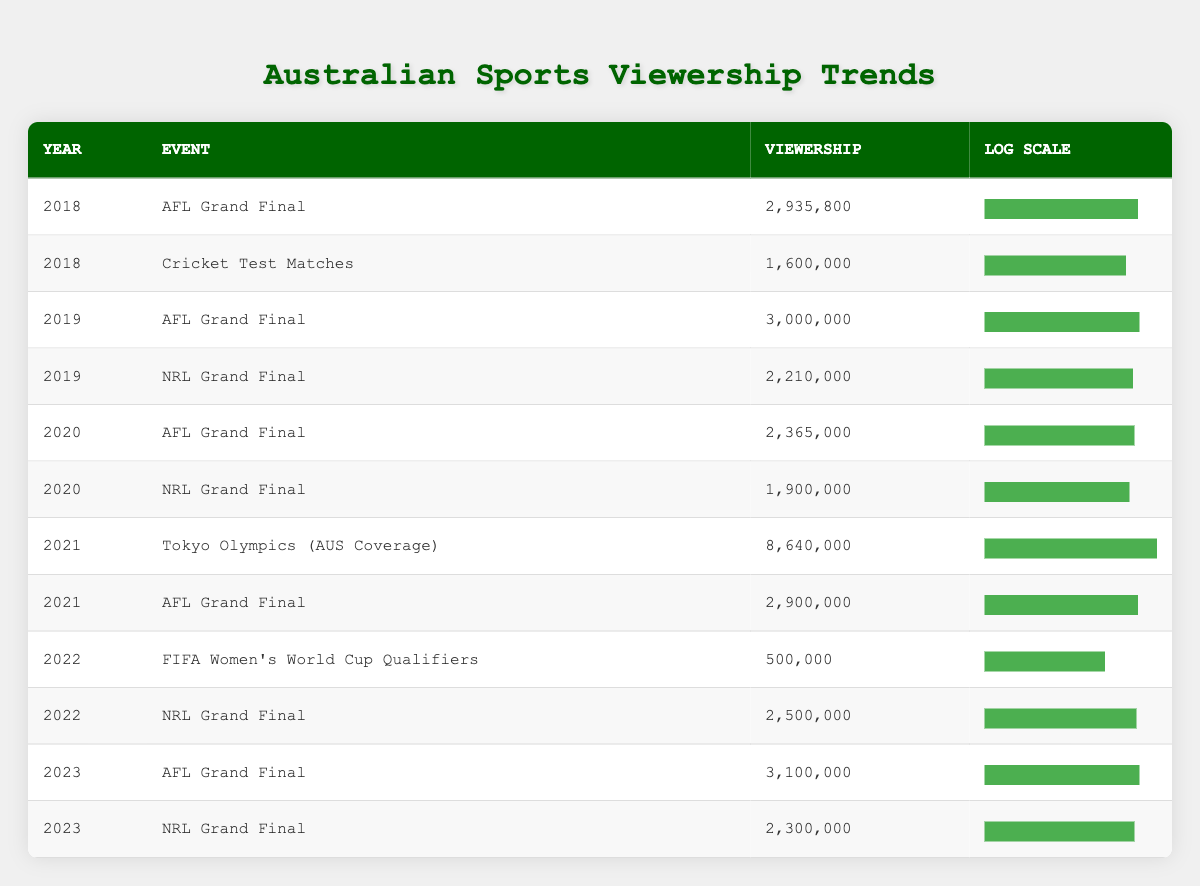What was the viewership for the AFL Grand Final in 2021? From the table, the row corresponding to the year 2021 shows that the viewership for the AFL Grand Final is 2,900,000.
Answer: 2,900,000 Which event had the highest viewership in 2021? In the table for 2021, the Tokyo Olympics (AUS Coverage) has a viewership of 8,640,000, which is higher than the 2,900,000 for the AFL Grand Final in the same year.
Answer: Tokyo Olympics (AUS Coverage) What is the difference in viewership between the NRL Grand Final in 2019 and 2023? The viewership for the NRL Grand Final in 2019 is 2,210,000 and in 2023 is 2,300,000. The difference is calculated by subtracting 2,210,000 from 2,300,000 which gives us 90,000.
Answer: 90,000 Was the viewership for the Cricket Test Matches in 2018 greater than 1.5 million? The data shows that the viewership for Cricket Test Matches in 2018 is 1,600,000, which is greater than 1.5 million. Therefore, the answer is yes.
Answer: Yes What is the average viewership of the AFL Grand Finals from 2018 to 2023? The AFL Grand Finals from 2018 to 2023 had viewership numbers of 2,935,800; 3,000,000; 2,365,000; 2,900,000; and 3,100,000. Adding these values gives us 14,300,800, and dividing by 5 gives an average viewership of 2,860,160.
Answer: 2,860,160 Which event had the lowest viewership in 2022? Reviewing the table for 2022, the FIFA Women's World Cup Qualifiers has a viewership of 500,000, which is lower than the 2,500,000 for the NRL Grand Final.
Answer: FIFA Women's World Cup Qualifiers Has the viewership for the AFL Grand Final increased every year since 2018? By checking the viewership for the AFL Grand Finals: 2,935,800 in 2018, 3,000,000 in 2019, 2,365,000 in 2020, 2,900,000 in 2021, 3,100,000 in 2023. It shows a decrease in 2020 making it not consistent.
Answer: No What was the total viewership for all events listed in 2021? The viewership for 2021 events were: Tokyo Olympics (AUS Coverage) 8,640,000 and AFL Grand Final 2,900,000. Adding these gives us a total of 8,640,000 + 2,900,000 = 11,540,000.
Answer: 11,540,000 